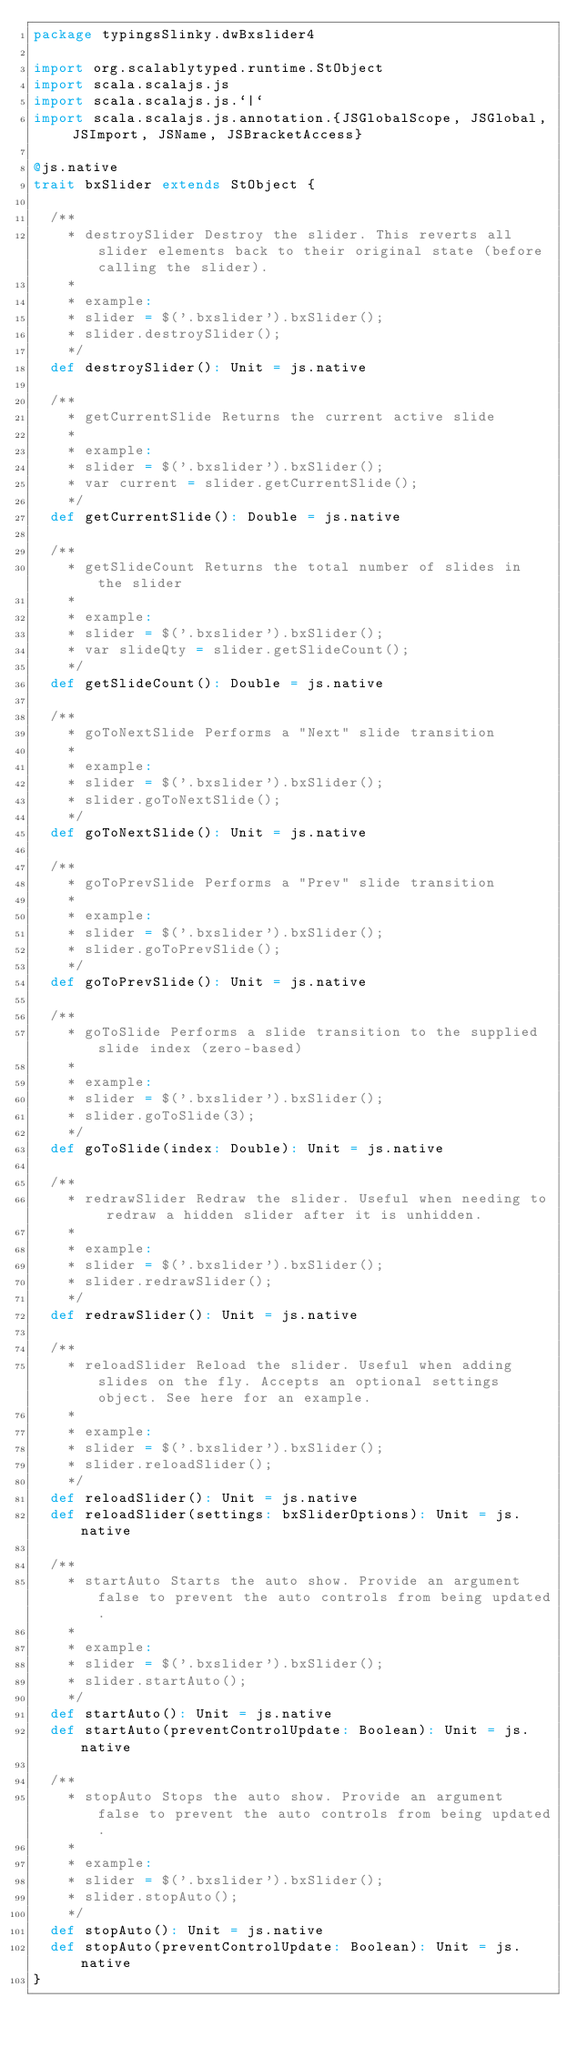<code> <loc_0><loc_0><loc_500><loc_500><_Scala_>package typingsSlinky.dwBxslider4

import org.scalablytyped.runtime.StObject
import scala.scalajs.js
import scala.scalajs.js.`|`
import scala.scalajs.js.annotation.{JSGlobalScope, JSGlobal, JSImport, JSName, JSBracketAccess}

@js.native
trait bxSlider extends StObject {
  
  /**
    * destroySlider Destroy the slider. This reverts all slider elements back to their original state (before calling the slider).
    * 
    * example:
    * slider = $('.bxslider').bxSlider();
    * slider.destroySlider();
    */
  def destroySlider(): Unit = js.native
  
  /**
    * getCurrentSlide Returns the current active slide
    * 
    * example:
    * slider = $('.bxslider').bxSlider();
    * var current = slider.getCurrentSlide();
    */
  def getCurrentSlide(): Double = js.native
  
  /**
    * getSlideCount Returns the total number of slides in the slider
    * 
    * example:
    * slider = $('.bxslider').bxSlider();
    * var slideQty = slider.getSlideCount();
    */
  def getSlideCount(): Double = js.native
  
  /**
    * goToNextSlide Performs a "Next" slide transition
    * 
    * example:
    * slider = $('.bxslider').bxSlider();
    * slider.goToNextSlide();
    */
  def goToNextSlide(): Unit = js.native
  
  /**
    * goToPrevSlide Performs a "Prev" slide transition
    * 
    * example:
    * slider = $('.bxslider').bxSlider();
    * slider.goToPrevSlide();
    */
  def goToPrevSlide(): Unit = js.native
  
  /**
    * goToSlide Performs a slide transition to the supplied slide index (zero-based)
    * 
    * example:
    * slider = $('.bxslider').bxSlider();
    * slider.goToSlide(3);
    */
  def goToSlide(index: Double): Unit = js.native
  
  /**
    * redrawSlider Redraw the slider. Useful when needing to redraw a hidden slider after it is unhidden.
    * 
    * example:
    * slider = $('.bxslider').bxSlider();
    * slider.redrawSlider();
    */
  def redrawSlider(): Unit = js.native
  
  /**
    * reloadSlider Reload the slider. Useful when adding slides on the fly. Accepts an optional settings object. See here for an example.
    * 
    * example:
    * slider = $('.bxslider').bxSlider();
    * slider.reloadSlider();
    */
  def reloadSlider(): Unit = js.native
  def reloadSlider(settings: bxSliderOptions): Unit = js.native
  
  /**
    * startAuto Starts the auto show. Provide an argument false to prevent the auto controls from being updated.
    * 
    * example:
    * slider = $('.bxslider').bxSlider();
    * slider.startAuto();
    */
  def startAuto(): Unit = js.native
  def startAuto(preventControlUpdate: Boolean): Unit = js.native
  
  /**
    * stopAuto Stops the auto show. Provide an argument false to prevent the auto controls from being updated.
    * 
    * example:
    * slider = $('.bxslider').bxSlider();
    * slider.stopAuto();
    */
  def stopAuto(): Unit = js.native
  def stopAuto(preventControlUpdate: Boolean): Unit = js.native
}
</code> 